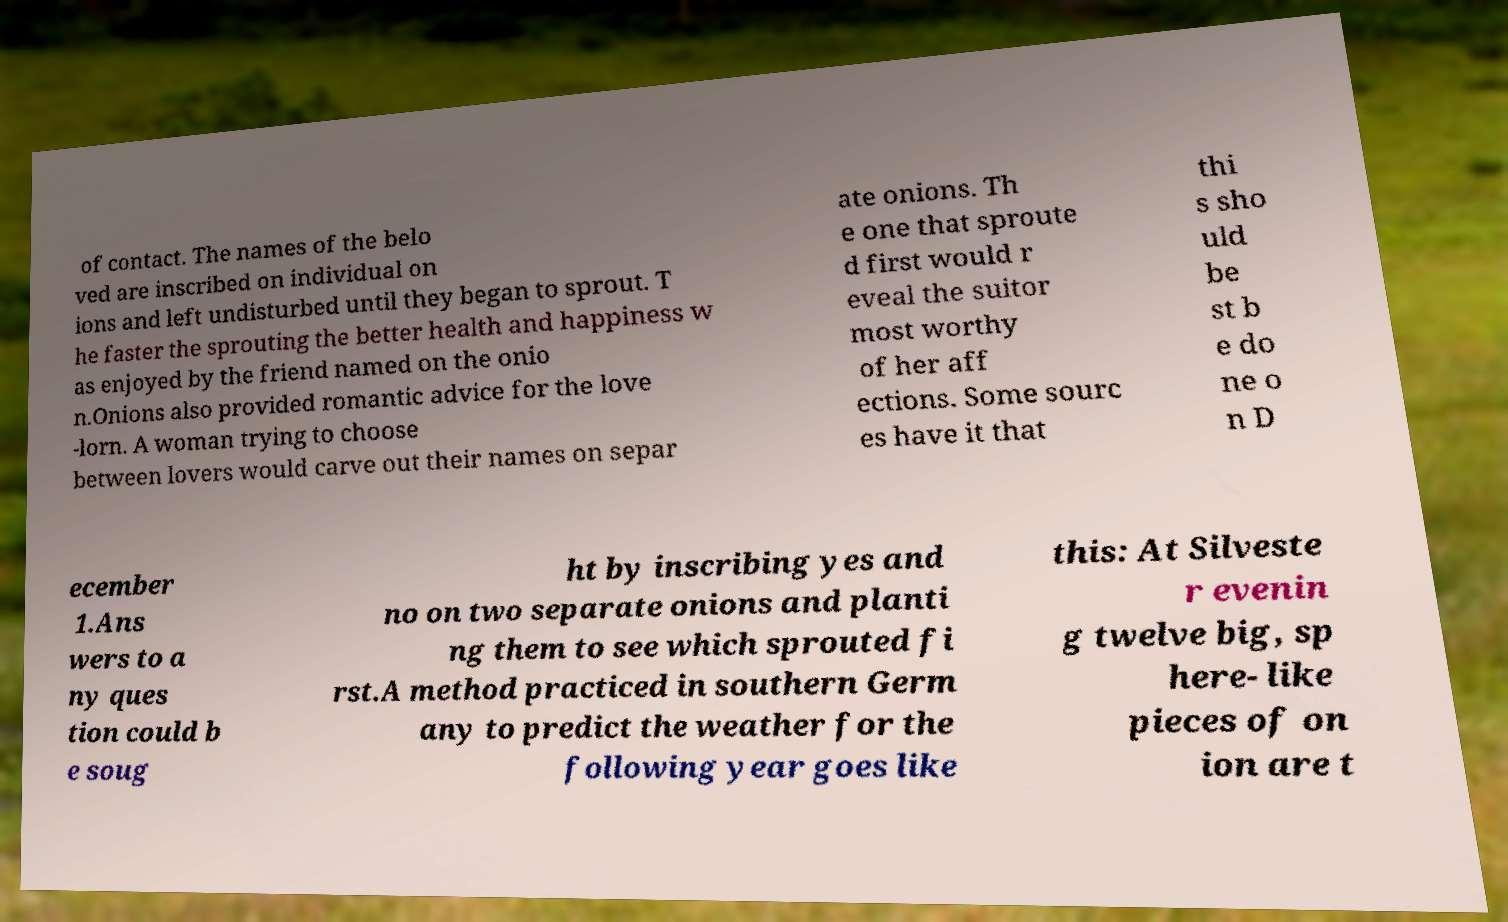Please identify and transcribe the text found in this image. of contact. The names of the belo ved are inscribed on individual on ions and left undisturbed until they began to sprout. T he faster the sprouting the better health and happiness w as enjoyed by the friend named on the onio n.Onions also provided romantic advice for the love -lorn. A woman trying to choose between lovers would carve out their names on separ ate onions. Th e one that sproute d first would r eveal the suitor most worthy of her aff ections. Some sourc es have it that thi s sho uld be st b e do ne o n D ecember 1.Ans wers to a ny ques tion could b e soug ht by inscribing yes and no on two separate onions and planti ng them to see which sprouted fi rst.A method practiced in southern Germ any to predict the weather for the following year goes like this: At Silveste r evenin g twelve big, sp here- like pieces of on ion are t 